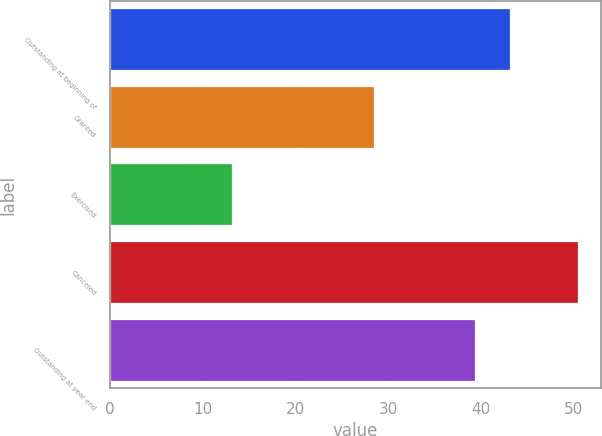<chart> <loc_0><loc_0><loc_500><loc_500><bar_chart><fcel>Outstanding at beginning of<fcel>Granted<fcel>Exercised<fcel>Canceled<fcel>Outstanding at year end<nl><fcel>43.09<fcel>28.5<fcel>13.11<fcel>50.42<fcel>39.36<nl></chart> 